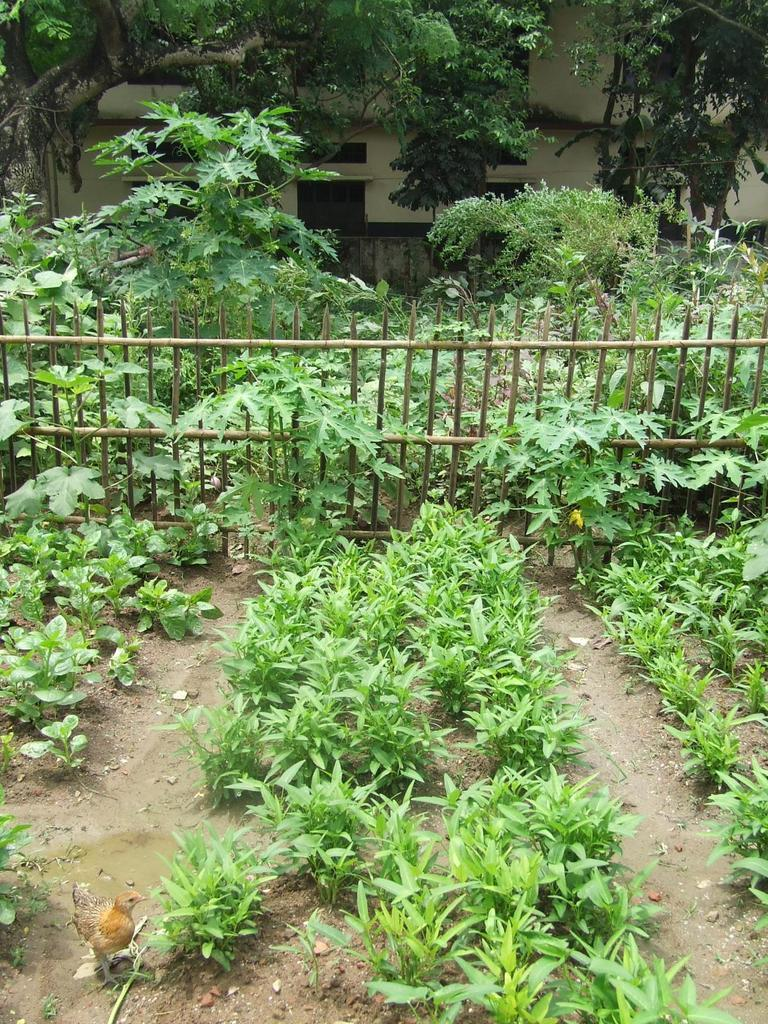What type of outdoor area is depicted in the image? There is a garden in the picture. What can be found within the garden? There are plants in the garden. What type of barrier surrounds the garden? There is an iron fence in the picture. What is located behind the fence? There are trees behind the fence. What other structures are present in the image? There is a wall and a building in the picture. What type of bells can be heard ringing in the garden? There are no bells present in the image, and therefore no sound can be heard. 